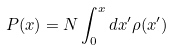Convert formula to latex. <formula><loc_0><loc_0><loc_500><loc_500>P ( x ) = N \int _ { 0 } ^ { x } d x ^ { \prime } \rho ( x ^ { \prime } )</formula> 